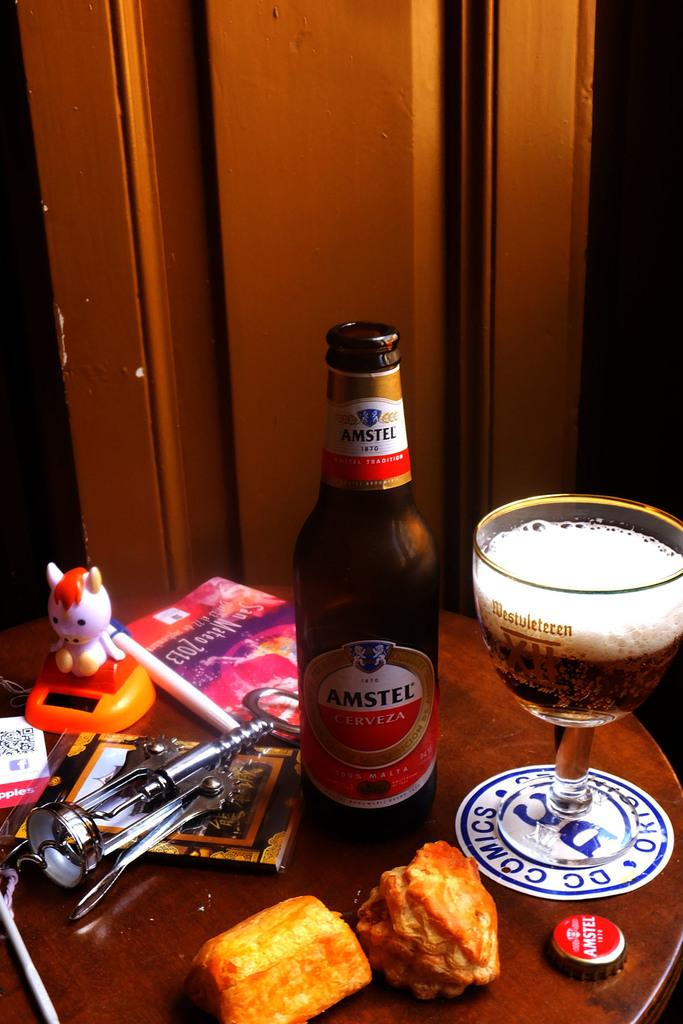<image>
Create a compact narrative representing the image presented. A table with an open bottle of Amstel beer, a half full beer chalice, a wine opener, and some pieces of food. 